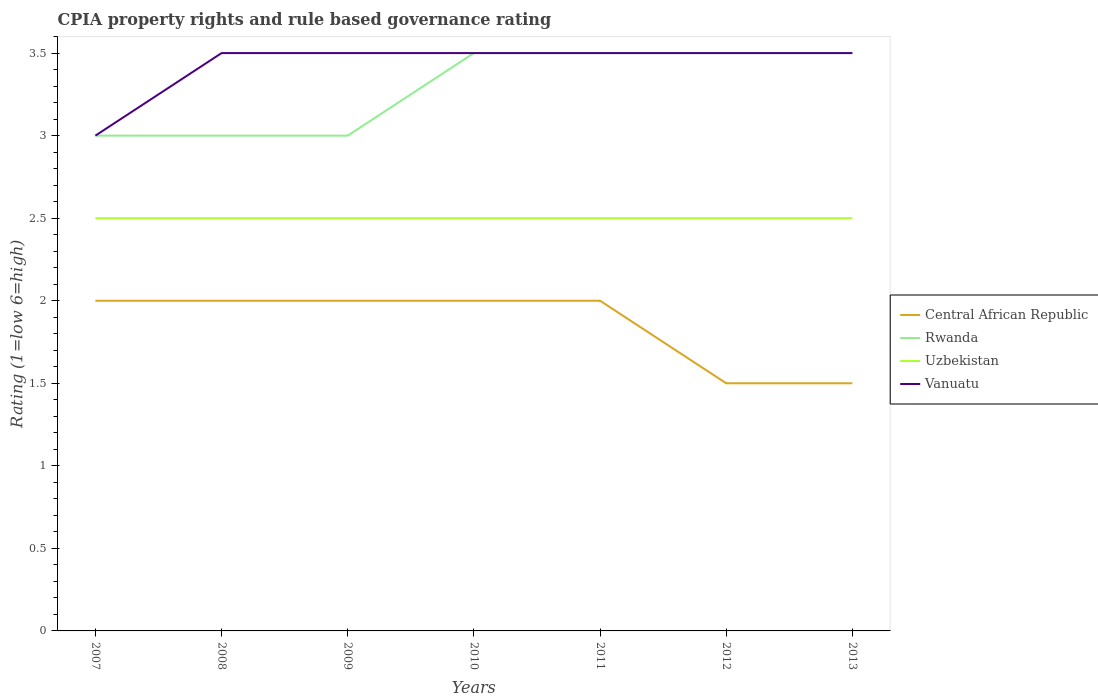Does the line corresponding to Vanuatu intersect with the line corresponding to Central African Republic?
Your answer should be very brief. No. Is the number of lines equal to the number of legend labels?
Offer a terse response. Yes. Across all years, what is the maximum CPIA rating in Rwanda?
Make the answer very short. 3. How many lines are there?
Give a very brief answer. 4. What is the difference between two consecutive major ticks on the Y-axis?
Your answer should be compact. 0.5. Are the values on the major ticks of Y-axis written in scientific E-notation?
Your answer should be very brief. No. Does the graph contain any zero values?
Your answer should be compact. No. How are the legend labels stacked?
Provide a succinct answer. Vertical. What is the title of the graph?
Provide a succinct answer. CPIA property rights and rule based governance rating. Does "Latin America(developing only)" appear as one of the legend labels in the graph?
Offer a terse response. No. What is the label or title of the X-axis?
Offer a very short reply. Years. What is the Rating (1=low 6=high) in Central African Republic in 2008?
Provide a short and direct response. 2. What is the Rating (1=low 6=high) of Rwanda in 2008?
Ensure brevity in your answer.  3. What is the Rating (1=low 6=high) in Uzbekistan in 2008?
Offer a very short reply. 2.5. What is the Rating (1=low 6=high) of Vanuatu in 2008?
Offer a very short reply. 3.5. What is the Rating (1=low 6=high) in Vanuatu in 2009?
Offer a terse response. 3.5. What is the Rating (1=low 6=high) of Rwanda in 2010?
Your answer should be compact. 3.5. What is the Rating (1=low 6=high) in Uzbekistan in 2010?
Your answer should be very brief. 2.5. What is the Rating (1=low 6=high) in Vanuatu in 2010?
Your answer should be compact. 3.5. What is the Rating (1=low 6=high) in Rwanda in 2011?
Offer a terse response. 3.5. What is the Rating (1=low 6=high) in Uzbekistan in 2011?
Offer a terse response. 2.5. What is the Rating (1=low 6=high) in Rwanda in 2012?
Your response must be concise. 3.5. What is the Rating (1=low 6=high) in Uzbekistan in 2012?
Ensure brevity in your answer.  2.5. What is the Rating (1=low 6=high) in Uzbekistan in 2013?
Offer a very short reply. 2.5. Across all years, what is the maximum Rating (1=low 6=high) of Uzbekistan?
Make the answer very short. 2.5. Across all years, what is the minimum Rating (1=low 6=high) in Central African Republic?
Your answer should be compact. 1.5. Across all years, what is the minimum Rating (1=low 6=high) of Rwanda?
Give a very brief answer. 3. Across all years, what is the minimum Rating (1=low 6=high) in Vanuatu?
Offer a very short reply. 3. What is the total Rating (1=low 6=high) of Rwanda in the graph?
Your response must be concise. 23. What is the difference between the Rating (1=low 6=high) in Central African Republic in 2007 and that in 2008?
Make the answer very short. 0. What is the difference between the Rating (1=low 6=high) in Uzbekistan in 2007 and that in 2008?
Provide a short and direct response. 0. What is the difference between the Rating (1=low 6=high) of Central African Republic in 2007 and that in 2009?
Keep it short and to the point. 0. What is the difference between the Rating (1=low 6=high) in Rwanda in 2007 and that in 2010?
Offer a very short reply. -0.5. What is the difference between the Rating (1=low 6=high) in Vanuatu in 2007 and that in 2010?
Provide a short and direct response. -0.5. What is the difference between the Rating (1=low 6=high) of Central African Republic in 2007 and that in 2011?
Your answer should be very brief. 0. What is the difference between the Rating (1=low 6=high) of Rwanda in 2007 and that in 2011?
Make the answer very short. -0.5. What is the difference between the Rating (1=low 6=high) in Vanuatu in 2007 and that in 2011?
Keep it short and to the point. -0.5. What is the difference between the Rating (1=low 6=high) of Central African Republic in 2007 and that in 2012?
Your response must be concise. 0.5. What is the difference between the Rating (1=low 6=high) of Vanuatu in 2007 and that in 2012?
Ensure brevity in your answer.  -0.5. What is the difference between the Rating (1=low 6=high) in Rwanda in 2007 and that in 2013?
Your response must be concise. -0.5. What is the difference between the Rating (1=low 6=high) of Vanuatu in 2008 and that in 2009?
Your answer should be very brief. 0. What is the difference between the Rating (1=low 6=high) of Central African Republic in 2008 and that in 2010?
Ensure brevity in your answer.  0. What is the difference between the Rating (1=low 6=high) in Uzbekistan in 2008 and that in 2010?
Offer a very short reply. 0. What is the difference between the Rating (1=low 6=high) in Vanuatu in 2008 and that in 2010?
Ensure brevity in your answer.  0. What is the difference between the Rating (1=low 6=high) in Uzbekistan in 2008 and that in 2011?
Provide a short and direct response. 0. What is the difference between the Rating (1=low 6=high) in Vanuatu in 2008 and that in 2011?
Give a very brief answer. 0. What is the difference between the Rating (1=low 6=high) of Rwanda in 2008 and that in 2012?
Provide a short and direct response. -0.5. What is the difference between the Rating (1=low 6=high) in Uzbekistan in 2008 and that in 2012?
Keep it short and to the point. 0. What is the difference between the Rating (1=low 6=high) of Uzbekistan in 2008 and that in 2013?
Your response must be concise. 0. What is the difference between the Rating (1=low 6=high) of Vanuatu in 2008 and that in 2013?
Give a very brief answer. 0. What is the difference between the Rating (1=low 6=high) in Uzbekistan in 2009 and that in 2010?
Make the answer very short. 0. What is the difference between the Rating (1=low 6=high) of Vanuatu in 2009 and that in 2010?
Offer a very short reply. 0. What is the difference between the Rating (1=low 6=high) of Rwanda in 2009 and that in 2012?
Ensure brevity in your answer.  -0.5. What is the difference between the Rating (1=low 6=high) in Rwanda in 2009 and that in 2013?
Your answer should be compact. -0.5. What is the difference between the Rating (1=low 6=high) in Vanuatu in 2009 and that in 2013?
Your answer should be compact. 0. What is the difference between the Rating (1=low 6=high) of Uzbekistan in 2010 and that in 2011?
Your answer should be very brief. 0. What is the difference between the Rating (1=low 6=high) in Central African Republic in 2010 and that in 2012?
Provide a succinct answer. 0.5. What is the difference between the Rating (1=low 6=high) in Uzbekistan in 2010 and that in 2012?
Ensure brevity in your answer.  0. What is the difference between the Rating (1=low 6=high) of Central African Republic in 2010 and that in 2013?
Offer a very short reply. 0.5. What is the difference between the Rating (1=low 6=high) of Rwanda in 2010 and that in 2013?
Give a very brief answer. 0. What is the difference between the Rating (1=low 6=high) of Uzbekistan in 2010 and that in 2013?
Your answer should be compact. 0. What is the difference between the Rating (1=low 6=high) of Vanuatu in 2010 and that in 2013?
Make the answer very short. 0. What is the difference between the Rating (1=low 6=high) of Rwanda in 2011 and that in 2012?
Offer a terse response. 0. What is the difference between the Rating (1=low 6=high) of Uzbekistan in 2011 and that in 2012?
Offer a very short reply. 0. What is the difference between the Rating (1=low 6=high) of Rwanda in 2011 and that in 2013?
Ensure brevity in your answer.  0. What is the difference between the Rating (1=low 6=high) in Vanuatu in 2011 and that in 2013?
Keep it short and to the point. 0. What is the difference between the Rating (1=low 6=high) in Uzbekistan in 2012 and that in 2013?
Your answer should be compact. 0. What is the difference between the Rating (1=low 6=high) in Central African Republic in 2007 and the Rating (1=low 6=high) in Vanuatu in 2008?
Give a very brief answer. -1.5. What is the difference between the Rating (1=low 6=high) of Rwanda in 2007 and the Rating (1=low 6=high) of Uzbekistan in 2008?
Keep it short and to the point. 0.5. What is the difference between the Rating (1=low 6=high) in Central African Republic in 2007 and the Rating (1=low 6=high) in Uzbekistan in 2009?
Your answer should be compact. -0.5. What is the difference between the Rating (1=low 6=high) of Rwanda in 2007 and the Rating (1=low 6=high) of Vanuatu in 2009?
Give a very brief answer. -0.5. What is the difference between the Rating (1=low 6=high) of Uzbekistan in 2007 and the Rating (1=low 6=high) of Vanuatu in 2009?
Keep it short and to the point. -1. What is the difference between the Rating (1=low 6=high) in Rwanda in 2007 and the Rating (1=low 6=high) in Uzbekistan in 2010?
Your response must be concise. 0.5. What is the difference between the Rating (1=low 6=high) in Central African Republic in 2007 and the Rating (1=low 6=high) in Rwanda in 2011?
Your answer should be very brief. -1.5. What is the difference between the Rating (1=low 6=high) in Central African Republic in 2007 and the Rating (1=low 6=high) in Uzbekistan in 2011?
Give a very brief answer. -0.5. What is the difference between the Rating (1=low 6=high) of Rwanda in 2007 and the Rating (1=low 6=high) of Uzbekistan in 2011?
Ensure brevity in your answer.  0.5. What is the difference between the Rating (1=low 6=high) of Rwanda in 2007 and the Rating (1=low 6=high) of Vanuatu in 2011?
Your answer should be very brief. -0.5. What is the difference between the Rating (1=low 6=high) in Uzbekistan in 2007 and the Rating (1=low 6=high) in Vanuatu in 2011?
Offer a terse response. -1. What is the difference between the Rating (1=low 6=high) of Central African Republic in 2007 and the Rating (1=low 6=high) of Vanuatu in 2012?
Give a very brief answer. -1.5. What is the difference between the Rating (1=low 6=high) of Rwanda in 2007 and the Rating (1=low 6=high) of Uzbekistan in 2012?
Ensure brevity in your answer.  0.5. What is the difference between the Rating (1=low 6=high) of Rwanda in 2007 and the Rating (1=low 6=high) of Vanuatu in 2012?
Ensure brevity in your answer.  -0.5. What is the difference between the Rating (1=low 6=high) in Uzbekistan in 2007 and the Rating (1=low 6=high) in Vanuatu in 2012?
Your answer should be very brief. -1. What is the difference between the Rating (1=low 6=high) of Central African Republic in 2007 and the Rating (1=low 6=high) of Rwanda in 2013?
Keep it short and to the point. -1.5. What is the difference between the Rating (1=low 6=high) in Central African Republic in 2007 and the Rating (1=low 6=high) in Uzbekistan in 2013?
Provide a succinct answer. -0.5. What is the difference between the Rating (1=low 6=high) in Central African Republic in 2007 and the Rating (1=low 6=high) in Vanuatu in 2013?
Provide a short and direct response. -1.5. What is the difference between the Rating (1=low 6=high) in Rwanda in 2007 and the Rating (1=low 6=high) in Uzbekistan in 2013?
Give a very brief answer. 0.5. What is the difference between the Rating (1=low 6=high) in Rwanda in 2007 and the Rating (1=low 6=high) in Vanuatu in 2013?
Offer a very short reply. -0.5. What is the difference between the Rating (1=low 6=high) of Uzbekistan in 2007 and the Rating (1=low 6=high) of Vanuatu in 2013?
Keep it short and to the point. -1. What is the difference between the Rating (1=low 6=high) of Central African Republic in 2008 and the Rating (1=low 6=high) of Rwanda in 2009?
Provide a short and direct response. -1. What is the difference between the Rating (1=low 6=high) of Central African Republic in 2008 and the Rating (1=low 6=high) of Vanuatu in 2009?
Your answer should be very brief. -1.5. What is the difference between the Rating (1=low 6=high) of Rwanda in 2008 and the Rating (1=low 6=high) of Uzbekistan in 2009?
Your response must be concise. 0.5. What is the difference between the Rating (1=low 6=high) in Rwanda in 2008 and the Rating (1=low 6=high) in Vanuatu in 2009?
Provide a succinct answer. -0.5. What is the difference between the Rating (1=low 6=high) of Uzbekistan in 2008 and the Rating (1=low 6=high) of Vanuatu in 2009?
Provide a short and direct response. -1. What is the difference between the Rating (1=low 6=high) in Central African Republic in 2008 and the Rating (1=low 6=high) in Rwanda in 2010?
Provide a short and direct response. -1.5. What is the difference between the Rating (1=low 6=high) of Central African Republic in 2008 and the Rating (1=low 6=high) of Uzbekistan in 2010?
Provide a succinct answer. -0.5. What is the difference between the Rating (1=low 6=high) of Rwanda in 2008 and the Rating (1=low 6=high) of Vanuatu in 2010?
Offer a terse response. -0.5. What is the difference between the Rating (1=low 6=high) of Uzbekistan in 2008 and the Rating (1=low 6=high) of Vanuatu in 2010?
Make the answer very short. -1. What is the difference between the Rating (1=low 6=high) of Central African Republic in 2008 and the Rating (1=low 6=high) of Rwanda in 2011?
Offer a very short reply. -1.5. What is the difference between the Rating (1=low 6=high) of Central African Republic in 2008 and the Rating (1=low 6=high) of Uzbekistan in 2011?
Your response must be concise. -0.5. What is the difference between the Rating (1=low 6=high) in Central African Republic in 2008 and the Rating (1=low 6=high) in Vanuatu in 2011?
Offer a very short reply. -1.5. What is the difference between the Rating (1=low 6=high) in Rwanda in 2008 and the Rating (1=low 6=high) in Uzbekistan in 2011?
Provide a succinct answer. 0.5. What is the difference between the Rating (1=low 6=high) of Uzbekistan in 2008 and the Rating (1=low 6=high) of Vanuatu in 2011?
Offer a terse response. -1. What is the difference between the Rating (1=low 6=high) in Central African Republic in 2008 and the Rating (1=low 6=high) in Rwanda in 2012?
Make the answer very short. -1.5. What is the difference between the Rating (1=low 6=high) in Rwanda in 2008 and the Rating (1=low 6=high) in Uzbekistan in 2012?
Your answer should be compact. 0.5. What is the difference between the Rating (1=low 6=high) of Rwanda in 2008 and the Rating (1=low 6=high) of Vanuatu in 2012?
Offer a terse response. -0.5. What is the difference between the Rating (1=low 6=high) of Uzbekistan in 2008 and the Rating (1=low 6=high) of Vanuatu in 2012?
Your answer should be compact. -1. What is the difference between the Rating (1=low 6=high) of Central African Republic in 2008 and the Rating (1=low 6=high) of Rwanda in 2013?
Offer a very short reply. -1.5. What is the difference between the Rating (1=low 6=high) of Central African Republic in 2008 and the Rating (1=low 6=high) of Vanuatu in 2013?
Give a very brief answer. -1.5. What is the difference between the Rating (1=low 6=high) in Rwanda in 2008 and the Rating (1=low 6=high) in Vanuatu in 2013?
Offer a terse response. -0.5. What is the difference between the Rating (1=low 6=high) in Central African Republic in 2009 and the Rating (1=low 6=high) in Rwanda in 2010?
Make the answer very short. -1.5. What is the difference between the Rating (1=low 6=high) of Central African Republic in 2009 and the Rating (1=low 6=high) of Uzbekistan in 2010?
Keep it short and to the point. -0.5. What is the difference between the Rating (1=low 6=high) of Uzbekistan in 2009 and the Rating (1=low 6=high) of Vanuatu in 2010?
Your answer should be compact. -1. What is the difference between the Rating (1=low 6=high) of Central African Republic in 2009 and the Rating (1=low 6=high) of Rwanda in 2011?
Make the answer very short. -1.5. What is the difference between the Rating (1=low 6=high) in Central African Republic in 2009 and the Rating (1=low 6=high) in Uzbekistan in 2011?
Give a very brief answer. -0.5. What is the difference between the Rating (1=low 6=high) in Rwanda in 2009 and the Rating (1=low 6=high) in Uzbekistan in 2011?
Give a very brief answer. 0.5. What is the difference between the Rating (1=low 6=high) in Rwanda in 2009 and the Rating (1=low 6=high) in Vanuatu in 2011?
Provide a short and direct response. -0.5. What is the difference between the Rating (1=low 6=high) of Uzbekistan in 2009 and the Rating (1=low 6=high) of Vanuatu in 2011?
Your response must be concise. -1. What is the difference between the Rating (1=low 6=high) of Central African Republic in 2009 and the Rating (1=low 6=high) of Uzbekistan in 2012?
Keep it short and to the point. -0.5. What is the difference between the Rating (1=low 6=high) in Rwanda in 2009 and the Rating (1=low 6=high) in Vanuatu in 2012?
Your answer should be compact. -0.5. What is the difference between the Rating (1=low 6=high) of Central African Republic in 2009 and the Rating (1=low 6=high) of Uzbekistan in 2013?
Ensure brevity in your answer.  -0.5. What is the difference between the Rating (1=low 6=high) of Rwanda in 2009 and the Rating (1=low 6=high) of Uzbekistan in 2013?
Offer a very short reply. 0.5. What is the difference between the Rating (1=low 6=high) of Uzbekistan in 2009 and the Rating (1=low 6=high) of Vanuatu in 2013?
Offer a very short reply. -1. What is the difference between the Rating (1=low 6=high) in Central African Republic in 2010 and the Rating (1=low 6=high) in Rwanda in 2011?
Your answer should be compact. -1.5. What is the difference between the Rating (1=low 6=high) in Central African Republic in 2010 and the Rating (1=low 6=high) in Vanuatu in 2011?
Your response must be concise. -1.5. What is the difference between the Rating (1=low 6=high) in Uzbekistan in 2010 and the Rating (1=low 6=high) in Vanuatu in 2011?
Provide a short and direct response. -1. What is the difference between the Rating (1=low 6=high) in Central African Republic in 2010 and the Rating (1=low 6=high) in Rwanda in 2012?
Give a very brief answer. -1.5. What is the difference between the Rating (1=low 6=high) in Central African Republic in 2010 and the Rating (1=low 6=high) in Uzbekistan in 2012?
Your answer should be very brief. -0.5. What is the difference between the Rating (1=low 6=high) in Rwanda in 2010 and the Rating (1=low 6=high) in Uzbekistan in 2012?
Your answer should be very brief. 1. What is the difference between the Rating (1=low 6=high) in Central African Republic in 2011 and the Rating (1=low 6=high) in Vanuatu in 2012?
Keep it short and to the point. -1.5. What is the difference between the Rating (1=low 6=high) of Rwanda in 2011 and the Rating (1=low 6=high) of Uzbekistan in 2012?
Give a very brief answer. 1. What is the difference between the Rating (1=low 6=high) of Central African Republic in 2011 and the Rating (1=low 6=high) of Uzbekistan in 2013?
Your answer should be compact. -0.5. What is the difference between the Rating (1=low 6=high) of Central African Republic in 2011 and the Rating (1=low 6=high) of Vanuatu in 2013?
Offer a terse response. -1.5. What is the difference between the Rating (1=low 6=high) of Rwanda in 2011 and the Rating (1=low 6=high) of Vanuatu in 2013?
Your response must be concise. 0. What is the difference between the Rating (1=low 6=high) of Uzbekistan in 2011 and the Rating (1=low 6=high) of Vanuatu in 2013?
Provide a succinct answer. -1. What is the difference between the Rating (1=low 6=high) of Central African Republic in 2012 and the Rating (1=low 6=high) of Uzbekistan in 2013?
Your response must be concise. -1. What is the difference between the Rating (1=low 6=high) of Central African Republic in 2012 and the Rating (1=low 6=high) of Vanuatu in 2013?
Provide a succinct answer. -2. What is the difference between the Rating (1=low 6=high) of Rwanda in 2012 and the Rating (1=low 6=high) of Uzbekistan in 2013?
Your answer should be compact. 1. What is the difference between the Rating (1=low 6=high) in Rwanda in 2012 and the Rating (1=low 6=high) in Vanuatu in 2013?
Offer a very short reply. 0. What is the difference between the Rating (1=low 6=high) of Uzbekistan in 2012 and the Rating (1=low 6=high) of Vanuatu in 2013?
Provide a succinct answer. -1. What is the average Rating (1=low 6=high) of Central African Republic per year?
Offer a terse response. 1.86. What is the average Rating (1=low 6=high) in Rwanda per year?
Offer a terse response. 3.29. What is the average Rating (1=low 6=high) of Vanuatu per year?
Offer a terse response. 3.43. In the year 2007, what is the difference between the Rating (1=low 6=high) in Central African Republic and Rating (1=low 6=high) in Rwanda?
Provide a succinct answer. -1. In the year 2007, what is the difference between the Rating (1=low 6=high) of Central African Republic and Rating (1=low 6=high) of Uzbekistan?
Keep it short and to the point. -0.5. In the year 2007, what is the difference between the Rating (1=low 6=high) in Central African Republic and Rating (1=low 6=high) in Vanuatu?
Keep it short and to the point. -1. In the year 2007, what is the difference between the Rating (1=low 6=high) in Rwanda and Rating (1=low 6=high) in Vanuatu?
Your answer should be compact. 0. In the year 2008, what is the difference between the Rating (1=low 6=high) in Central African Republic and Rating (1=low 6=high) in Rwanda?
Your answer should be compact. -1. In the year 2008, what is the difference between the Rating (1=low 6=high) of Central African Republic and Rating (1=low 6=high) of Uzbekistan?
Offer a very short reply. -0.5. In the year 2008, what is the difference between the Rating (1=low 6=high) in Central African Republic and Rating (1=low 6=high) in Vanuatu?
Offer a very short reply. -1.5. In the year 2009, what is the difference between the Rating (1=low 6=high) of Central African Republic and Rating (1=low 6=high) of Rwanda?
Your answer should be very brief. -1. In the year 2009, what is the difference between the Rating (1=low 6=high) of Rwanda and Rating (1=low 6=high) of Uzbekistan?
Keep it short and to the point. 0.5. In the year 2009, what is the difference between the Rating (1=low 6=high) in Rwanda and Rating (1=low 6=high) in Vanuatu?
Give a very brief answer. -0.5. In the year 2009, what is the difference between the Rating (1=low 6=high) in Uzbekistan and Rating (1=low 6=high) in Vanuatu?
Provide a short and direct response. -1. In the year 2010, what is the difference between the Rating (1=low 6=high) in Central African Republic and Rating (1=low 6=high) in Rwanda?
Give a very brief answer. -1.5. In the year 2010, what is the difference between the Rating (1=low 6=high) of Rwanda and Rating (1=low 6=high) of Uzbekistan?
Make the answer very short. 1. In the year 2010, what is the difference between the Rating (1=low 6=high) of Rwanda and Rating (1=low 6=high) of Vanuatu?
Your answer should be very brief. 0. In the year 2011, what is the difference between the Rating (1=low 6=high) in Central African Republic and Rating (1=low 6=high) in Rwanda?
Keep it short and to the point. -1.5. In the year 2011, what is the difference between the Rating (1=low 6=high) in Central African Republic and Rating (1=low 6=high) in Vanuatu?
Provide a succinct answer. -1.5. In the year 2011, what is the difference between the Rating (1=low 6=high) of Uzbekistan and Rating (1=low 6=high) of Vanuatu?
Your answer should be compact. -1. In the year 2012, what is the difference between the Rating (1=low 6=high) of Central African Republic and Rating (1=low 6=high) of Uzbekistan?
Your response must be concise. -1. In the year 2012, what is the difference between the Rating (1=low 6=high) of Central African Republic and Rating (1=low 6=high) of Vanuatu?
Your answer should be compact. -2. In the year 2012, what is the difference between the Rating (1=low 6=high) in Rwanda and Rating (1=low 6=high) in Uzbekistan?
Provide a short and direct response. 1. In the year 2012, what is the difference between the Rating (1=low 6=high) in Rwanda and Rating (1=low 6=high) in Vanuatu?
Offer a terse response. 0. In the year 2012, what is the difference between the Rating (1=low 6=high) of Uzbekistan and Rating (1=low 6=high) of Vanuatu?
Your answer should be very brief. -1. In the year 2013, what is the difference between the Rating (1=low 6=high) in Central African Republic and Rating (1=low 6=high) in Uzbekistan?
Provide a succinct answer. -1. In the year 2013, what is the difference between the Rating (1=low 6=high) in Central African Republic and Rating (1=low 6=high) in Vanuatu?
Your answer should be very brief. -2. In the year 2013, what is the difference between the Rating (1=low 6=high) in Rwanda and Rating (1=low 6=high) in Uzbekistan?
Keep it short and to the point. 1. What is the ratio of the Rating (1=low 6=high) in Central African Republic in 2007 to that in 2008?
Your response must be concise. 1. What is the ratio of the Rating (1=low 6=high) of Rwanda in 2007 to that in 2008?
Make the answer very short. 1. What is the ratio of the Rating (1=low 6=high) of Uzbekistan in 2007 to that in 2008?
Your response must be concise. 1. What is the ratio of the Rating (1=low 6=high) in Central African Republic in 2007 to that in 2009?
Your response must be concise. 1. What is the ratio of the Rating (1=low 6=high) in Rwanda in 2007 to that in 2009?
Offer a very short reply. 1. What is the ratio of the Rating (1=low 6=high) in Uzbekistan in 2007 to that in 2009?
Your answer should be very brief. 1. What is the ratio of the Rating (1=low 6=high) in Vanuatu in 2007 to that in 2009?
Ensure brevity in your answer.  0.86. What is the ratio of the Rating (1=low 6=high) in Uzbekistan in 2007 to that in 2011?
Ensure brevity in your answer.  1. What is the ratio of the Rating (1=low 6=high) in Central African Republic in 2007 to that in 2012?
Your answer should be very brief. 1.33. What is the ratio of the Rating (1=low 6=high) in Rwanda in 2007 to that in 2012?
Ensure brevity in your answer.  0.86. What is the ratio of the Rating (1=low 6=high) of Uzbekistan in 2007 to that in 2012?
Your answer should be compact. 1. What is the ratio of the Rating (1=low 6=high) of Vanuatu in 2007 to that in 2012?
Provide a short and direct response. 0.86. What is the ratio of the Rating (1=low 6=high) in Vanuatu in 2007 to that in 2013?
Your response must be concise. 0.86. What is the ratio of the Rating (1=low 6=high) of Central African Republic in 2008 to that in 2009?
Make the answer very short. 1. What is the ratio of the Rating (1=low 6=high) in Uzbekistan in 2008 to that in 2009?
Provide a short and direct response. 1. What is the ratio of the Rating (1=low 6=high) of Vanuatu in 2008 to that in 2009?
Offer a terse response. 1. What is the ratio of the Rating (1=low 6=high) of Rwanda in 2008 to that in 2010?
Keep it short and to the point. 0.86. What is the ratio of the Rating (1=low 6=high) of Vanuatu in 2008 to that in 2010?
Offer a very short reply. 1. What is the ratio of the Rating (1=low 6=high) of Central African Republic in 2008 to that in 2011?
Offer a terse response. 1. What is the ratio of the Rating (1=low 6=high) of Rwanda in 2008 to that in 2011?
Your answer should be compact. 0.86. What is the ratio of the Rating (1=low 6=high) in Uzbekistan in 2008 to that in 2011?
Make the answer very short. 1. What is the ratio of the Rating (1=low 6=high) of Vanuatu in 2008 to that in 2011?
Give a very brief answer. 1. What is the ratio of the Rating (1=low 6=high) in Rwanda in 2008 to that in 2012?
Give a very brief answer. 0.86. What is the ratio of the Rating (1=low 6=high) in Uzbekistan in 2008 to that in 2012?
Your answer should be compact. 1. What is the ratio of the Rating (1=low 6=high) in Vanuatu in 2008 to that in 2012?
Provide a short and direct response. 1. What is the ratio of the Rating (1=low 6=high) in Rwanda in 2008 to that in 2013?
Give a very brief answer. 0.86. What is the ratio of the Rating (1=low 6=high) in Vanuatu in 2008 to that in 2013?
Provide a short and direct response. 1. What is the ratio of the Rating (1=low 6=high) in Central African Republic in 2009 to that in 2011?
Provide a succinct answer. 1. What is the ratio of the Rating (1=low 6=high) in Vanuatu in 2009 to that in 2011?
Your answer should be compact. 1. What is the ratio of the Rating (1=low 6=high) of Uzbekistan in 2009 to that in 2013?
Your answer should be compact. 1. What is the ratio of the Rating (1=low 6=high) of Rwanda in 2010 to that in 2011?
Your response must be concise. 1. What is the ratio of the Rating (1=low 6=high) in Vanuatu in 2010 to that in 2011?
Keep it short and to the point. 1. What is the ratio of the Rating (1=low 6=high) in Central African Republic in 2010 to that in 2012?
Offer a very short reply. 1.33. What is the ratio of the Rating (1=low 6=high) in Vanuatu in 2010 to that in 2012?
Provide a succinct answer. 1. What is the ratio of the Rating (1=low 6=high) of Central African Republic in 2010 to that in 2013?
Provide a short and direct response. 1.33. What is the ratio of the Rating (1=low 6=high) in Rwanda in 2010 to that in 2013?
Offer a very short reply. 1. What is the ratio of the Rating (1=low 6=high) of Vanuatu in 2010 to that in 2013?
Offer a terse response. 1. What is the ratio of the Rating (1=low 6=high) of Rwanda in 2011 to that in 2012?
Offer a very short reply. 1. What is the ratio of the Rating (1=low 6=high) of Vanuatu in 2011 to that in 2012?
Keep it short and to the point. 1. What is the ratio of the Rating (1=low 6=high) of Rwanda in 2011 to that in 2013?
Your response must be concise. 1. What is the ratio of the Rating (1=low 6=high) of Vanuatu in 2011 to that in 2013?
Ensure brevity in your answer.  1. What is the ratio of the Rating (1=low 6=high) of Central African Republic in 2012 to that in 2013?
Make the answer very short. 1. What is the ratio of the Rating (1=low 6=high) in Rwanda in 2012 to that in 2013?
Your answer should be very brief. 1. What is the ratio of the Rating (1=low 6=high) of Vanuatu in 2012 to that in 2013?
Your answer should be compact. 1. What is the difference between the highest and the lowest Rating (1=low 6=high) of Central African Republic?
Make the answer very short. 0.5. What is the difference between the highest and the lowest Rating (1=low 6=high) in Rwanda?
Give a very brief answer. 0.5. What is the difference between the highest and the lowest Rating (1=low 6=high) in Uzbekistan?
Make the answer very short. 0. 